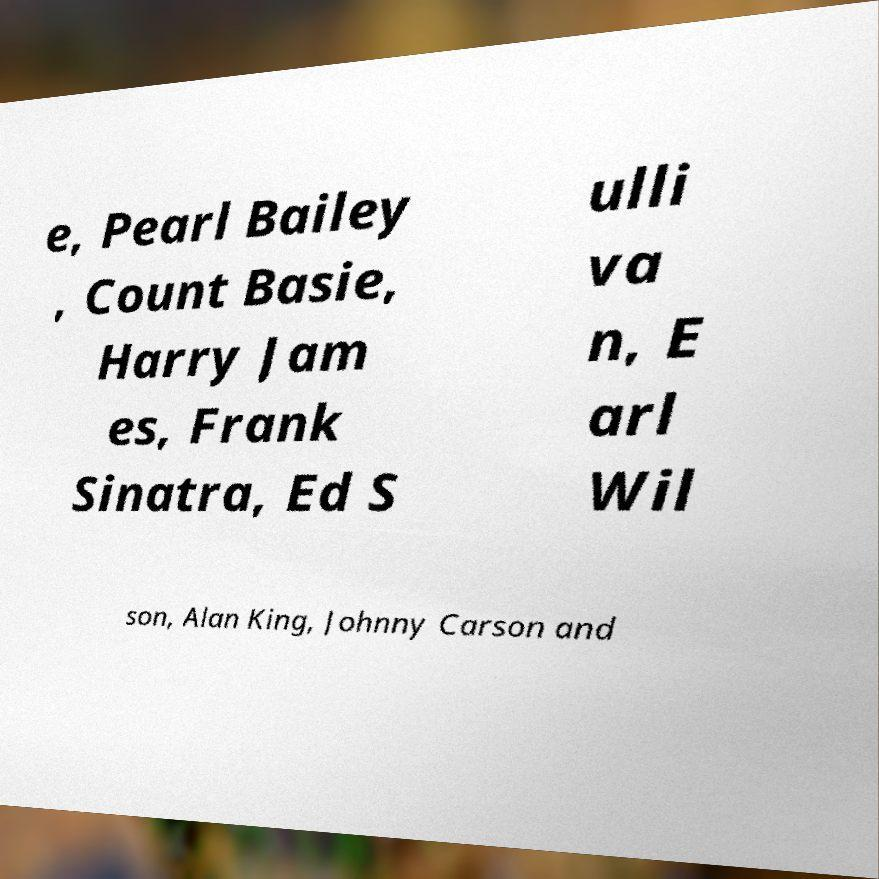Could you assist in decoding the text presented in this image and type it out clearly? e, Pearl Bailey , Count Basie, Harry Jam es, Frank Sinatra, Ed S ulli va n, E arl Wil son, Alan King, Johnny Carson and 